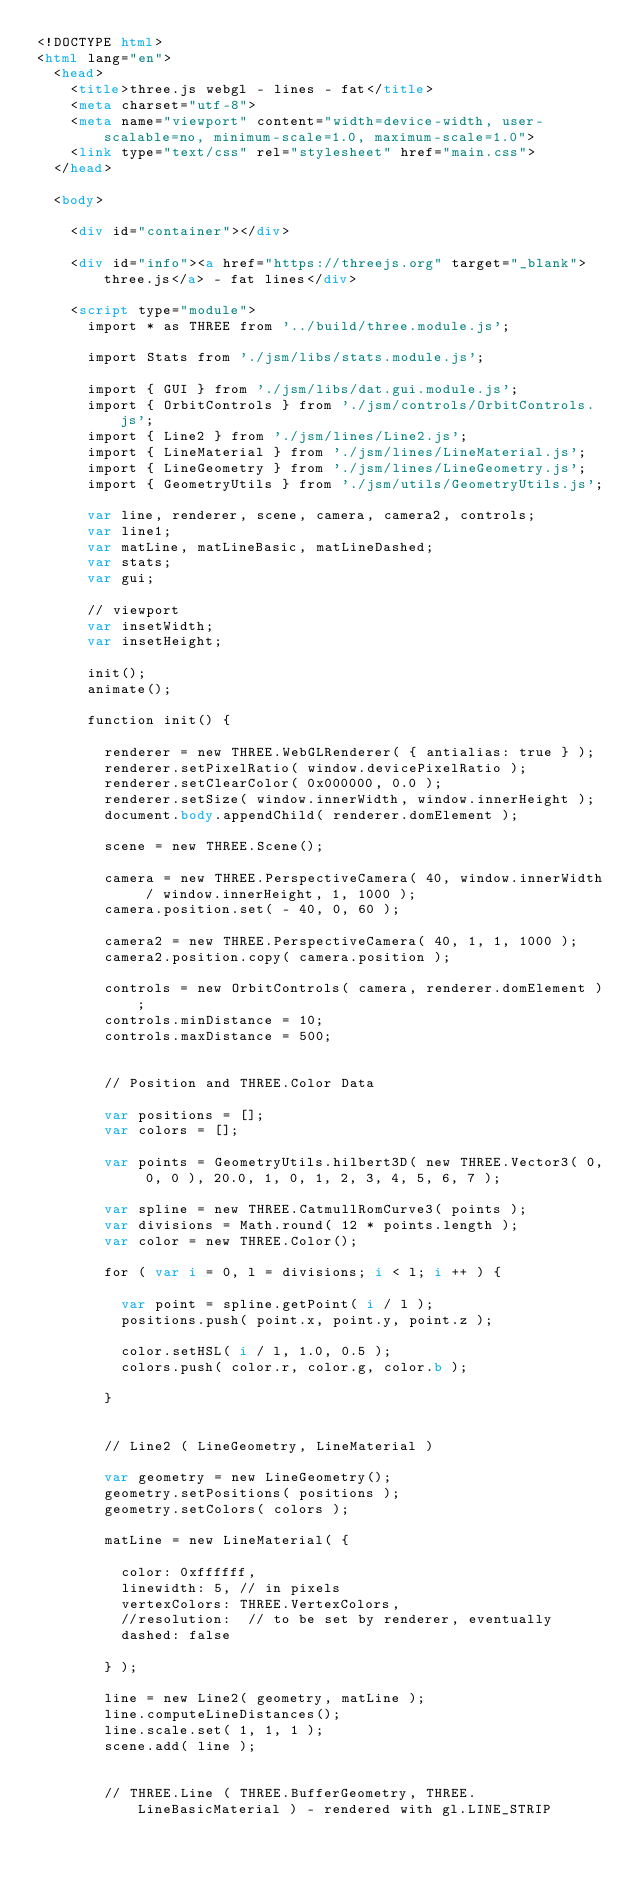<code> <loc_0><loc_0><loc_500><loc_500><_HTML_><!DOCTYPE html>
<html lang="en">
	<head>
		<title>three.js webgl - lines - fat</title>
		<meta charset="utf-8">
		<meta name="viewport" content="width=device-width, user-scalable=no, minimum-scale=1.0, maximum-scale=1.0">
		<link type="text/css" rel="stylesheet" href="main.css">
	</head>

	<body>

		<div id="container"></div>

		<div id="info"><a href="https://threejs.org" target="_blank">three.js</a> - fat lines</div>

		<script type="module">
			import * as THREE from '../build/three.module.js';

			import Stats from './jsm/libs/stats.module.js';

			import { GUI } from './jsm/libs/dat.gui.module.js';
			import { OrbitControls } from './jsm/controls/OrbitControls.js';
			import { Line2 } from './jsm/lines/Line2.js';
			import { LineMaterial } from './jsm/lines/LineMaterial.js';
			import { LineGeometry } from './jsm/lines/LineGeometry.js';
			import { GeometryUtils } from './jsm/utils/GeometryUtils.js';

			var line, renderer, scene, camera, camera2, controls;
			var line1;
			var matLine, matLineBasic, matLineDashed;
			var stats;
			var gui;

			// viewport
			var insetWidth;
			var insetHeight;

			init();
			animate();

			function init() {

				renderer = new THREE.WebGLRenderer( { antialias: true } );
				renderer.setPixelRatio( window.devicePixelRatio );
				renderer.setClearColor( 0x000000, 0.0 );
				renderer.setSize( window.innerWidth, window.innerHeight );
				document.body.appendChild( renderer.domElement );

				scene = new THREE.Scene();

				camera = new THREE.PerspectiveCamera( 40, window.innerWidth / window.innerHeight, 1, 1000 );
				camera.position.set( - 40, 0, 60 );

				camera2 = new THREE.PerspectiveCamera( 40, 1, 1, 1000 );
				camera2.position.copy( camera.position );

				controls = new OrbitControls( camera, renderer.domElement );
				controls.minDistance = 10;
				controls.maxDistance = 500;


				// Position and THREE.Color Data

				var positions = [];
				var colors = [];

				var points = GeometryUtils.hilbert3D( new THREE.Vector3( 0, 0, 0 ), 20.0, 1, 0, 1, 2, 3, 4, 5, 6, 7 );

				var spline = new THREE.CatmullRomCurve3( points );
				var divisions = Math.round( 12 * points.length );
				var color = new THREE.Color();

				for ( var i = 0, l = divisions; i < l; i ++ ) {

					var point = spline.getPoint( i / l );
					positions.push( point.x, point.y, point.z );

					color.setHSL( i / l, 1.0, 0.5 );
					colors.push( color.r, color.g, color.b );

				}


				// Line2 ( LineGeometry, LineMaterial )

				var geometry = new LineGeometry();
				geometry.setPositions( positions );
				geometry.setColors( colors );

				matLine = new LineMaterial( {

					color: 0xffffff,
					linewidth: 5, // in pixels
					vertexColors: THREE.VertexColors,
					//resolution:  // to be set by renderer, eventually
					dashed: false

				} );

				line = new Line2( geometry, matLine );
				line.computeLineDistances();
				line.scale.set( 1, 1, 1 );
				scene.add( line );


				// THREE.Line ( THREE.BufferGeometry, THREE.LineBasicMaterial ) - rendered with gl.LINE_STRIP
</code> 